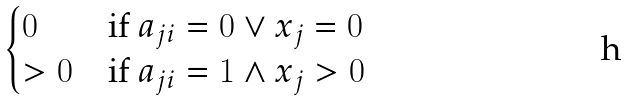Convert formula to latex. <formula><loc_0><loc_0><loc_500><loc_500>\begin{cases} 0 & \text {if } a _ { j i } = 0 \vee x _ { j } = 0 \\ > 0 & \text {if } a _ { j i } = 1 \wedge x _ { j } > 0 \end{cases}</formula> 